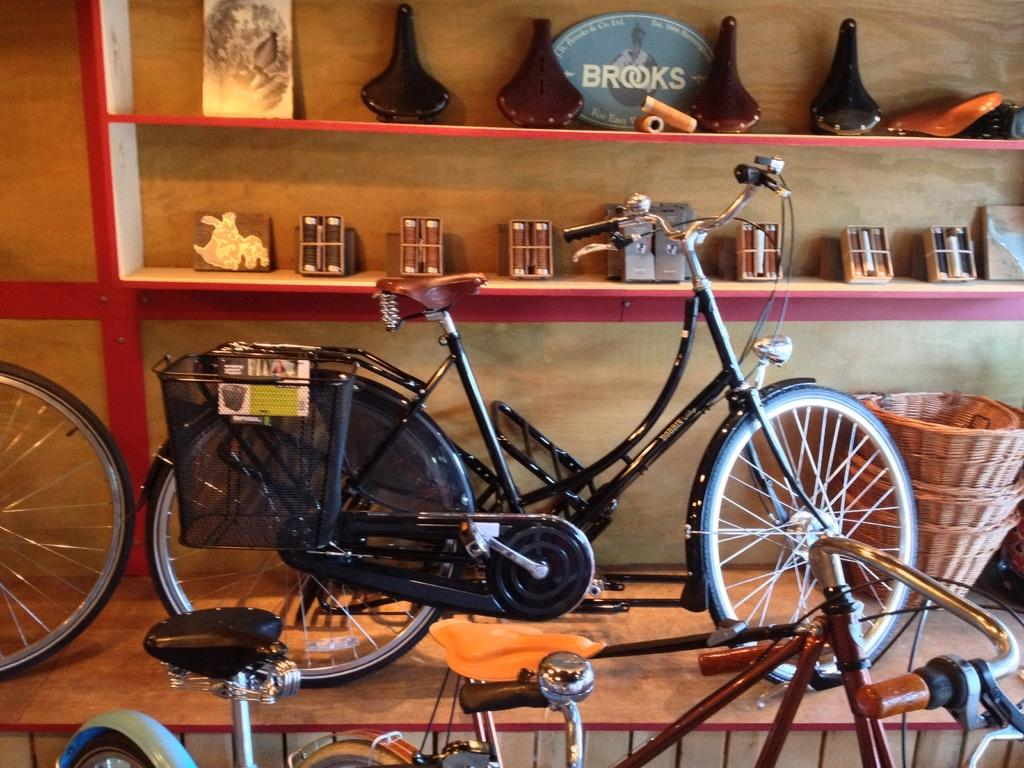What type of objects can be seen in the image? There are bicycles in the image. What can be found on the shelves in the image? The shelves contain frames, vases, thread rolls, boxes, and baskets. How does the business of digestion take place in the image? There is no reference to digestion or a business in the image; it features bicycles and shelves with various items. 